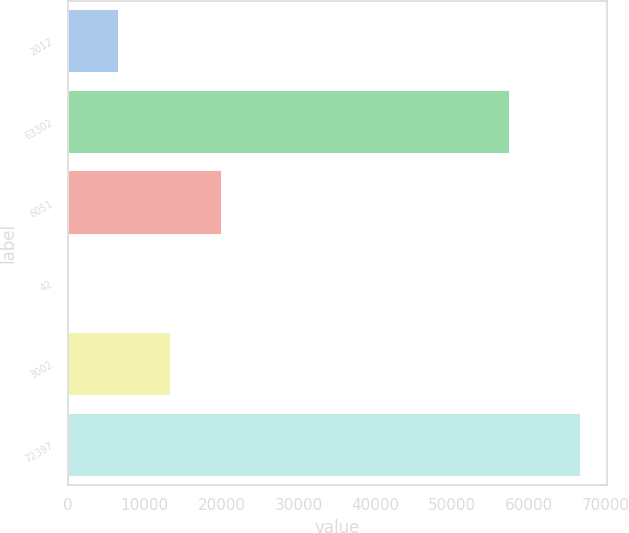Convert chart. <chart><loc_0><loc_0><loc_500><loc_500><bar_chart><fcel>2012<fcel>63302<fcel>6051<fcel>42<fcel>3002<fcel>72397<nl><fcel>6716.7<fcel>57556<fcel>20064.1<fcel>43<fcel>13390.4<fcel>66780<nl></chart> 